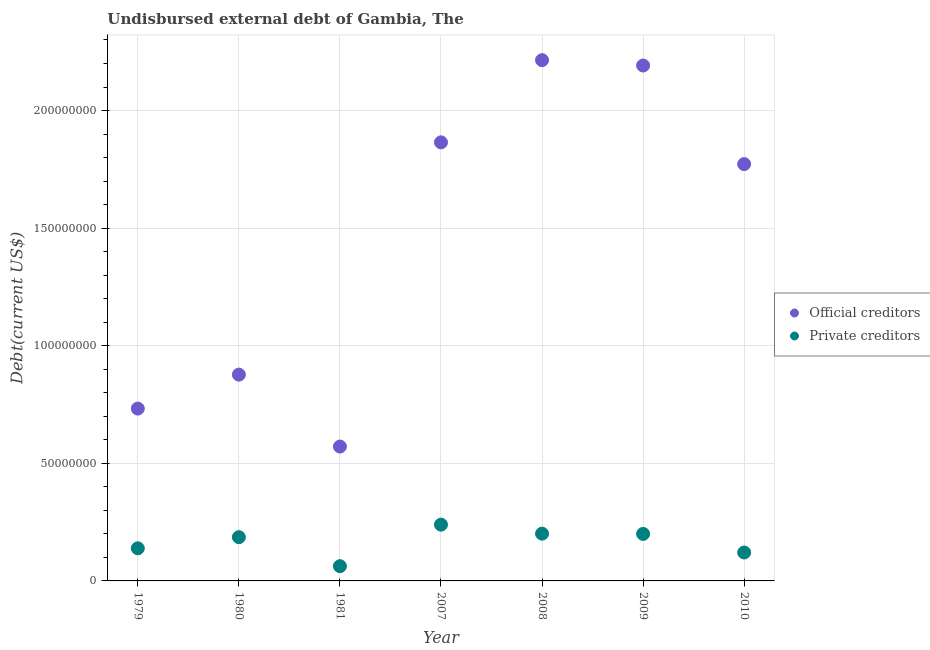Is the number of dotlines equal to the number of legend labels?
Keep it short and to the point. Yes. What is the undisbursed external debt of private creditors in 2009?
Give a very brief answer. 2.00e+07. Across all years, what is the maximum undisbursed external debt of official creditors?
Provide a succinct answer. 2.21e+08. Across all years, what is the minimum undisbursed external debt of official creditors?
Provide a succinct answer. 5.71e+07. In which year was the undisbursed external debt of private creditors maximum?
Provide a short and direct response. 2007. What is the total undisbursed external debt of official creditors in the graph?
Keep it short and to the point. 1.02e+09. What is the difference between the undisbursed external debt of official creditors in 1980 and that in 2008?
Ensure brevity in your answer.  -1.34e+08. What is the difference between the undisbursed external debt of official creditors in 2010 and the undisbursed external debt of private creditors in 2009?
Offer a terse response. 1.57e+08. What is the average undisbursed external debt of official creditors per year?
Offer a very short reply. 1.46e+08. In the year 2008, what is the difference between the undisbursed external debt of official creditors and undisbursed external debt of private creditors?
Provide a short and direct response. 2.01e+08. In how many years, is the undisbursed external debt of private creditors greater than 170000000 US$?
Your answer should be compact. 0. What is the ratio of the undisbursed external debt of official creditors in 1981 to that in 2008?
Your response must be concise. 0.26. Is the undisbursed external debt of official creditors in 1981 less than that in 2008?
Provide a succinct answer. Yes. Is the difference between the undisbursed external debt of private creditors in 1981 and 2007 greater than the difference between the undisbursed external debt of official creditors in 1981 and 2007?
Provide a succinct answer. Yes. What is the difference between the highest and the second highest undisbursed external debt of private creditors?
Ensure brevity in your answer.  3.83e+06. What is the difference between the highest and the lowest undisbursed external debt of private creditors?
Offer a very short reply. 1.77e+07. In how many years, is the undisbursed external debt of private creditors greater than the average undisbursed external debt of private creditors taken over all years?
Provide a succinct answer. 4. Is the sum of the undisbursed external debt of official creditors in 1980 and 2009 greater than the maximum undisbursed external debt of private creditors across all years?
Make the answer very short. Yes. Does the undisbursed external debt of private creditors monotonically increase over the years?
Your response must be concise. No. Is the undisbursed external debt of official creditors strictly less than the undisbursed external debt of private creditors over the years?
Provide a short and direct response. No. How many years are there in the graph?
Your response must be concise. 7. Are the values on the major ticks of Y-axis written in scientific E-notation?
Offer a very short reply. No. Where does the legend appear in the graph?
Provide a succinct answer. Center right. How many legend labels are there?
Keep it short and to the point. 2. What is the title of the graph?
Keep it short and to the point. Undisbursed external debt of Gambia, The. What is the label or title of the X-axis?
Ensure brevity in your answer.  Year. What is the label or title of the Y-axis?
Offer a very short reply. Debt(current US$). What is the Debt(current US$) of Official creditors in 1979?
Your answer should be very brief. 7.33e+07. What is the Debt(current US$) in Private creditors in 1979?
Keep it short and to the point. 1.39e+07. What is the Debt(current US$) in Official creditors in 1980?
Provide a succinct answer. 8.77e+07. What is the Debt(current US$) of Private creditors in 1980?
Give a very brief answer. 1.86e+07. What is the Debt(current US$) in Official creditors in 1981?
Offer a terse response. 5.71e+07. What is the Debt(current US$) in Private creditors in 1981?
Offer a very short reply. 6.27e+06. What is the Debt(current US$) of Official creditors in 2007?
Your answer should be compact. 1.86e+08. What is the Debt(current US$) in Private creditors in 2007?
Your answer should be compact. 2.39e+07. What is the Debt(current US$) of Official creditors in 2008?
Your answer should be very brief. 2.21e+08. What is the Debt(current US$) of Private creditors in 2008?
Give a very brief answer. 2.01e+07. What is the Debt(current US$) of Official creditors in 2009?
Ensure brevity in your answer.  2.19e+08. What is the Debt(current US$) of Private creditors in 2009?
Offer a very short reply. 2.00e+07. What is the Debt(current US$) in Official creditors in 2010?
Your answer should be compact. 1.77e+08. What is the Debt(current US$) of Private creditors in 2010?
Offer a very short reply. 1.21e+07. Across all years, what is the maximum Debt(current US$) of Official creditors?
Provide a succinct answer. 2.21e+08. Across all years, what is the maximum Debt(current US$) of Private creditors?
Offer a terse response. 2.39e+07. Across all years, what is the minimum Debt(current US$) in Official creditors?
Provide a short and direct response. 5.71e+07. Across all years, what is the minimum Debt(current US$) of Private creditors?
Your answer should be very brief. 6.27e+06. What is the total Debt(current US$) of Official creditors in the graph?
Keep it short and to the point. 1.02e+09. What is the total Debt(current US$) of Private creditors in the graph?
Your answer should be very brief. 1.15e+08. What is the difference between the Debt(current US$) of Official creditors in 1979 and that in 1980?
Offer a very short reply. -1.44e+07. What is the difference between the Debt(current US$) in Private creditors in 1979 and that in 1980?
Offer a very short reply. -4.72e+06. What is the difference between the Debt(current US$) in Official creditors in 1979 and that in 1981?
Give a very brief answer. 1.61e+07. What is the difference between the Debt(current US$) of Private creditors in 1979 and that in 1981?
Offer a terse response. 7.60e+06. What is the difference between the Debt(current US$) of Official creditors in 1979 and that in 2007?
Keep it short and to the point. -1.13e+08. What is the difference between the Debt(current US$) of Private creditors in 1979 and that in 2007?
Your answer should be very brief. -1.01e+07. What is the difference between the Debt(current US$) in Official creditors in 1979 and that in 2008?
Give a very brief answer. -1.48e+08. What is the difference between the Debt(current US$) in Private creditors in 1979 and that in 2008?
Make the answer very short. -6.23e+06. What is the difference between the Debt(current US$) of Official creditors in 1979 and that in 2009?
Offer a terse response. -1.46e+08. What is the difference between the Debt(current US$) of Private creditors in 1979 and that in 2009?
Offer a very short reply. -6.12e+06. What is the difference between the Debt(current US$) in Official creditors in 1979 and that in 2010?
Provide a short and direct response. -1.04e+08. What is the difference between the Debt(current US$) of Private creditors in 1979 and that in 2010?
Your answer should be very brief. 1.78e+06. What is the difference between the Debt(current US$) in Official creditors in 1980 and that in 1981?
Give a very brief answer. 3.06e+07. What is the difference between the Debt(current US$) of Private creditors in 1980 and that in 1981?
Ensure brevity in your answer.  1.23e+07. What is the difference between the Debt(current US$) in Official creditors in 1980 and that in 2007?
Your answer should be very brief. -9.88e+07. What is the difference between the Debt(current US$) of Private creditors in 1980 and that in 2007?
Offer a terse response. -5.34e+06. What is the difference between the Debt(current US$) of Official creditors in 1980 and that in 2008?
Your answer should be very brief. -1.34e+08. What is the difference between the Debt(current US$) in Private creditors in 1980 and that in 2008?
Provide a short and direct response. -1.51e+06. What is the difference between the Debt(current US$) of Official creditors in 1980 and that in 2009?
Your answer should be compact. -1.31e+08. What is the difference between the Debt(current US$) in Private creditors in 1980 and that in 2009?
Your answer should be very brief. -1.40e+06. What is the difference between the Debt(current US$) in Official creditors in 1980 and that in 2010?
Offer a terse response. -8.95e+07. What is the difference between the Debt(current US$) in Private creditors in 1980 and that in 2010?
Provide a short and direct response. 6.51e+06. What is the difference between the Debt(current US$) of Official creditors in 1981 and that in 2007?
Ensure brevity in your answer.  -1.29e+08. What is the difference between the Debt(current US$) in Private creditors in 1981 and that in 2007?
Your answer should be compact. -1.77e+07. What is the difference between the Debt(current US$) in Official creditors in 1981 and that in 2008?
Give a very brief answer. -1.64e+08. What is the difference between the Debt(current US$) of Private creditors in 1981 and that in 2008?
Keep it short and to the point. -1.38e+07. What is the difference between the Debt(current US$) in Official creditors in 1981 and that in 2009?
Provide a short and direct response. -1.62e+08. What is the difference between the Debt(current US$) in Private creditors in 1981 and that in 2009?
Provide a succinct answer. -1.37e+07. What is the difference between the Debt(current US$) of Official creditors in 1981 and that in 2010?
Your answer should be very brief. -1.20e+08. What is the difference between the Debt(current US$) of Private creditors in 1981 and that in 2010?
Provide a succinct answer. -5.82e+06. What is the difference between the Debt(current US$) in Official creditors in 2007 and that in 2008?
Offer a very short reply. -3.49e+07. What is the difference between the Debt(current US$) in Private creditors in 2007 and that in 2008?
Give a very brief answer. 3.83e+06. What is the difference between the Debt(current US$) in Official creditors in 2007 and that in 2009?
Ensure brevity in your answer.  -3.27e+07. What is the difference between the Debt(current US$) in Private creditors in 2007 and that in 2009?
Provide a short and direct response. 3.94e+06. What is the difference between the Debt(current US$) of Official creditors in 2007 and that in 2010?
Provide a succinct answer. 9.25e+06. What is the difference between the Debt(current US$) in Private creditors in 2007 and that in 2010?
Ensure brevity in your answer.  1.18e+07. What is the difference between the Debt(current US$) in Official creditors in 2008 and that in 2009?
Offer a very short reply. 2.27e+06. What is the difference between the Debt(current US$) of Private creditors in 2008 and that in 2009?
Make the answer very short. 1.05e+05. What is the difference between the Debt(current US$) in Official creditors in 2008 and that in 2010?
Keep it short and to the point. 4.42e+07. What is the difference between the Debt(current US$) of Private creditors in 2008 and that in 2010?
Your answer should be very brief. 8.01e+06. What is the difference between the Debt(current US$) of Official creditors in 2009 and that in 2010?
Provide a succinct answer. 4.19e+07. What is the difference between the Debt(current US$) of Private creditors in 2009 and that in 2010?
Your answer should be compact. 7.91e+06. What is the difference between the Debt(current US$) of Official creditors in 1979 and the Debt(current US$) of Private creditors in 1980?
Offer a very short reply. 5.47e+07. What is the difference between the Debt(current US$) in Official creditors in 1979 and the Debt(current US$) in Private creditors in 1981?
Your answer should be compact. 6.70e+07. What is the difference between the Debt(current US$) in Official creditors in 1979 and the Debt(current US$) in Private creditors in 2007?
Offer a very short reply. 4.94e+07. What is the difference between the Debt(current US$) in Official creditors in 1979 and the Debt(current US$) in Private creditors in 2008?
Provide a short and direct response. 5.32e+07. What is the difference between the Debt(current US$) in Official creditors in 1979 and the Debt(current US$) in Private creditors in 2009?
Ensure brevity in your answer.  5.33e+07. What is the difference between the Debt(current US$) in Official creditors in 1979 and the Debt(current US$) in Private creditors in 2010?
Offer a terse response. 6.12e+07. What is the difference between the Debt(current US$) in Official creditors in 1980 and the Debt(current US$) in Private creditors in 1981?
Your answer should be compact. 8.15e+07. What is the difference between the Debt(current US$) in Official creditors in 1980 and the Debt(current US$) in Private creditors in 2007?
Your response must be concise. 6.38e+07. What is the difference between the Debt(current US$) in Official creditors in 1980 and the Debt(current US$) in Private creditors in 2008?
Ensure brevity in your answer.  6.76e+07. What is the difference between the Debt(current US$) of Official creditors in 1980 and the Debt(current US$) of Private creditors in 2009?
Provide a succinct answer. 6.77e+07. What is the difference between the Debt(current US$) of Official creditors in 1980 and the Debt(current US$) of Private creditors in 2010?
Offer a very short reply. 7.56e+07. What is the difference between the Debt(current US$) of Official creditors in 1981 and the Debt(current US$) of Private creditors in 2007?
Keep it short and to the point. 3.32e+07. What is the difference between the Debt(current US$) in Official creditors in 1981 and the Debt(current US$) in Private creditors in 2008?
Your answer should be very brief. 3.70e+07. What is the difference between the Debt(current US$) in Official creditors in 1981 and the Debt(current US$) in Private creditors in 2009?
Provide a short and direct response. 3.71e+07. What is the difference between the Debt(current US$) of Official creditors in 1981 and the Debt(current US$) of Private creditors in 2010?
Offer a very short reply. 4.51e+07. What is the difference between the Debt(current US$) in Official creditors in 2007 and the Debt(current US$) in Private creditors in 2008?
Provide a succinct answer. 1.66e+08. What is the difference between the Debt(current US$) in Official creditors in 2007 and the Debt(current US$) in Private creditors in 2009?
Your response must be concise. 1.66e+08. What is the difference between the Debt(current US$) of Official creditors in 2007 and the Debt(current US$) of Private creditors in 2010?
Offer a terse response. 1.74e+08. What is the difference between the Debt(current US$) in Official creditors in 2008 and the Debt(current US$) in Private creditors in 2009?
Ensure brevity in your answer.  2.01e+08. What is the difference between the Debt(current US$) in Official creditors in 2008 and the Debt(current US$) in Private creditors in 2010?
Make the answer very short. 2.09e+08. What is the difference between the Debt(current US$) of Official creditors in 2009 and the Debt(current US$) of Private creditors in 2010?
Provide a short and direct response. 2.07e+08. What is the average Debt(current US$) in Official creditors per year?
Your response must be concise. 1.46e+08. What is the average Debt(current US$) in Private creditors per year?
Your response must be concise. 1.64e+07. In the year 1979, what is the difference between the Debt(current US$) of Official creditors and Debt(current US$) of Private creditors?
Provide a short and direct response. 5.94e+07. In the year 1980, what is the difference between the Debt(current US$) in Official creditors and Debt(current US$) in Private creditors?
Offer a very short reply. 6.91e+07. In the year 1981, what is the difference between the Debt(current US$) in Official creditors and Debt(current US$) in Private creditors?
Give a very brief answer. 5.09e+07. In the year 2007, what is the difference between the Debt(current US$) of Official creditors and Debt(current US$) of Private creditors?
Make the answer very short. 1.63e+08. In the year 2008, what is the difference between the Debt(current US$) in Official creditors and Debt(current US$) in Private creditors?
Give a very brief answer. 2.01e+08. In the year 2009, what is the difference between the Debt(current US$) of Official creditors and Debt(current US$) of Private creditors?
Your answer should be very brief. 1.99e+08. In the year 2010, what is the difference between the Debt(current US$) in Official creditors and Debt(current US$) in Private creditors?
Ensure brevity in your answer.  1.65e+08. What is the ratio of the Debt(current US$) in Official creditors in 1979 to that in 1980?
Your response must be concise. 0.84. What is the ratio of the Debt(current US$) of Private creditors in 1979 to that in 1980?
Provide a succinct answer. 0.75. What is the ratio of the Debt(current US$) in Official creditors in 1979 to that in 1981?
Offer a terse response. 1.28. What is the ratio of the Debt(current US$) of Private creditors in 1979 to that in 1981?
Ensure brevity in your answer.  2.21. What is the ratio of the Debt(current US$) of Official creditors in 1979 to that in 2007?
Ensure brevity in your answer.  0.39. What is the ratio of the Debt(current US$) in Private creditors in 1979 to that in 2007?
Your response must be concise. 0.58. What is the ratio of the Debt(current US$) of Official creditors in 1979 to that in 2008?
Keep it short and to the point. 0.33. What is the ratio of the Debt(current US$) in Private creditors in 1979 to that in 2008?
Your answer should be compact. 0.69. What is the ratio of the Debt(current US$) in Official creditors in 1979 to that in 2009?
Your answer should be compact. 0.33. What is the ratio of the Debt(current US$) of Private creditors in 1979 to that in 2009?
Keep it short and to the point. 0.69. What is the ratio of the Debt(current US$) of Official creditors in 1979 to that in 2010?
Give a very brief answer. 0.41. What is the ratio of the Debt(current US$) in Private creditors in 1979 to that in 2010?
Your answer should be compact. 1.15. What is the ratio of the Debt(current US$) in Official creditors in 1980 to that in 1981?
Make the answer very short. 1.54. What is the ratio of the Debt(current US$) in Private creditors in 1980 to that in 1981?
Offer a terse response. 2.97. What is the ratio of the Debt(current US$) in Official creditors in 1980 to that in 2007?
Offer a terse response. 0.47. What is the ratio of the Debt(current US$) in Private creditors in 1980 to that in 2007?
Your response must be concise. 0.78. What is the ratio of the Debt(current US$) of Official creditors in 1980 to that in 2008?
Give a very brief answer. 0.4. What is the ratio of the Debt(current US$) of Private creditors in 1980 to that in 2008?
Give a very brief answer. 0.93. What is the ratio of the Debt(current US$) of Official creditors in 1980 to that in 2009?
Offer a very short reply. 0.4. What is the ratio of the Debt(current US$) of Private creditors in 1980 to that in 2009?
Offer a terse response. 0.93. What is the ratio of the Debt(current US$) of Official creditors in 1980 to that in 2010?
Offer a very short reply. 0.49. What is the ratio of the Debt(current US$) in Private creditors in 1980 to that in 2010?
Your response must be concise. 1.54. What is the ratio of the Debt(current US$) of Official creditors in 1981 to that in 2007?
Ensure brevity in your answer.  0.31. What is the ratio of the Debt(current US$) of Private creditors in 1981 to that in 2007?
Offer a terse response. 0.26. What is the ratio of the Debt(current US$) of Official creditors in 1981 to that in 2008?
Offer a terse response. 0.26. What is the ratio of the Debt(current US$) in Private creditors in 1981 to that in 2008?
Make the answer very short. 0.31. What is the ratio of the Debt(current US$) of Official creditors in 1981 to that in 2009?
Your answer should be very brief. 0.26. What is the ratio of the Debt(current US$) in Private creditors in 1981 to that in 2009?
Provide a short and direct response. 0.31. What is the ratio of the Debt(current US$) of Official creditors in 1981 to that in 2010?
Provide a short and direct response. 0.32. What is the ratio of the Debt(current US$) of Private creditors in 1981 to that in 2010?
Offer a terse response. 0.52. What is the ratio of the Debt(current US$) in Official creditors in 2007 to that in 2008?
Your answer should be very brief. 0.84. What is the ratio of the Debt(current US$) in Private creditors in 2007 to that in 2008?
Offer a terse response. 1.19. What is the ratio of the Debt(current US$) of Official creditors in 2007 to that in 2009?
Provide a succinct answer. 0.85. What is the ratio of the Debt(current US$) of Private creditors in 2007 to that in 2009?
Your answer should be very brief. 1.2. What is the ratio of the Debt(current US$) in Official creditors in 2007 to that in 2010?
Offer a terse response. 1.05. What is the ratio of the Debt(current US$) in Private creditors in 2007 to that in 2010?
Provide a short and direct response. 1.98. What is the ratio of the Debt(current US$) in Official creditors in 2008 to that in 2009?
Keep it short and to the point. 1.01. What is the ratio of the Debt(current US$) of Official creditors in 2008 to that in 2010?
Provide a short and direct response. 1.25. What is the ratio of the Debt(current US$) of Private creditors in 2008 to that in 2010?
Make the answer very short. 1.66. What is the ratio of the Debt(current US$) in Official creditors in 2009 to that in 2010?
Provide a short and direct response. 1.24. What is the ratio of the Debt(current US$) of Private creditors in 2009 to that in 2010?
Make the answer very short. 1.65. What is the difference between the highest and the second highest Debt(current US$) of Official creditors?
Your answer should be compact. 2.27e+06. What is the difference between the highest and the second highest Debt(current US$) in Private creditors?
Keep it short and to the point. 3.83e+06. What is the difference between the highest and the lowest Debt(current US$) in Official creditors?
Your answer should be very brief. 1.64e+08. What is the difference between the highest and the lowest Debt(current US$) of Private creditors?
Provide a succinct answer. 1.77e+07. 